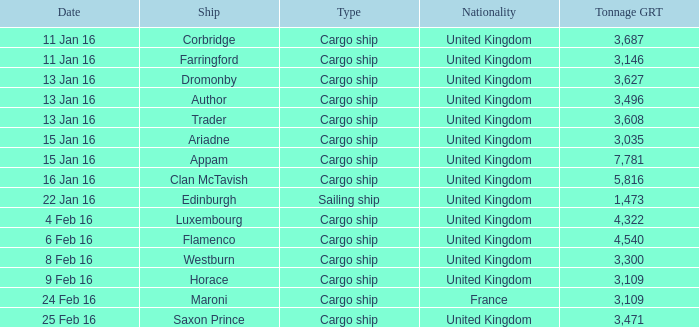What is the tonnage grt of the ship author? 3496.0. 